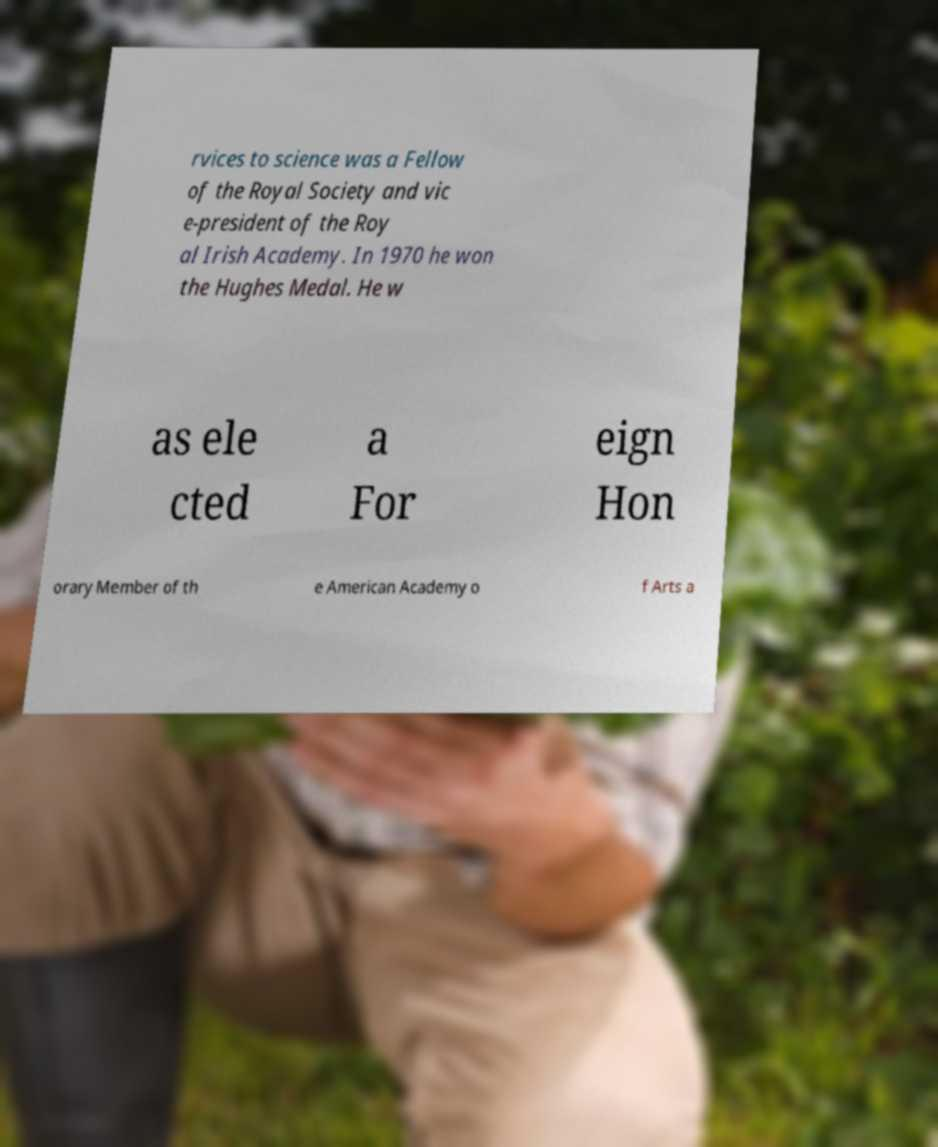Can you read and provide the text displayed in the image?This photo seems to have some interesting text. Can you extract and type it out for me? rvices to science was a Fellow of the Royal Society and vic e-president of the Roy al Irish Academy. In 1970 he won the Hughes Medal. He w as ele cted a For eign Hon orary Member of th e American Academy o f Arts a 